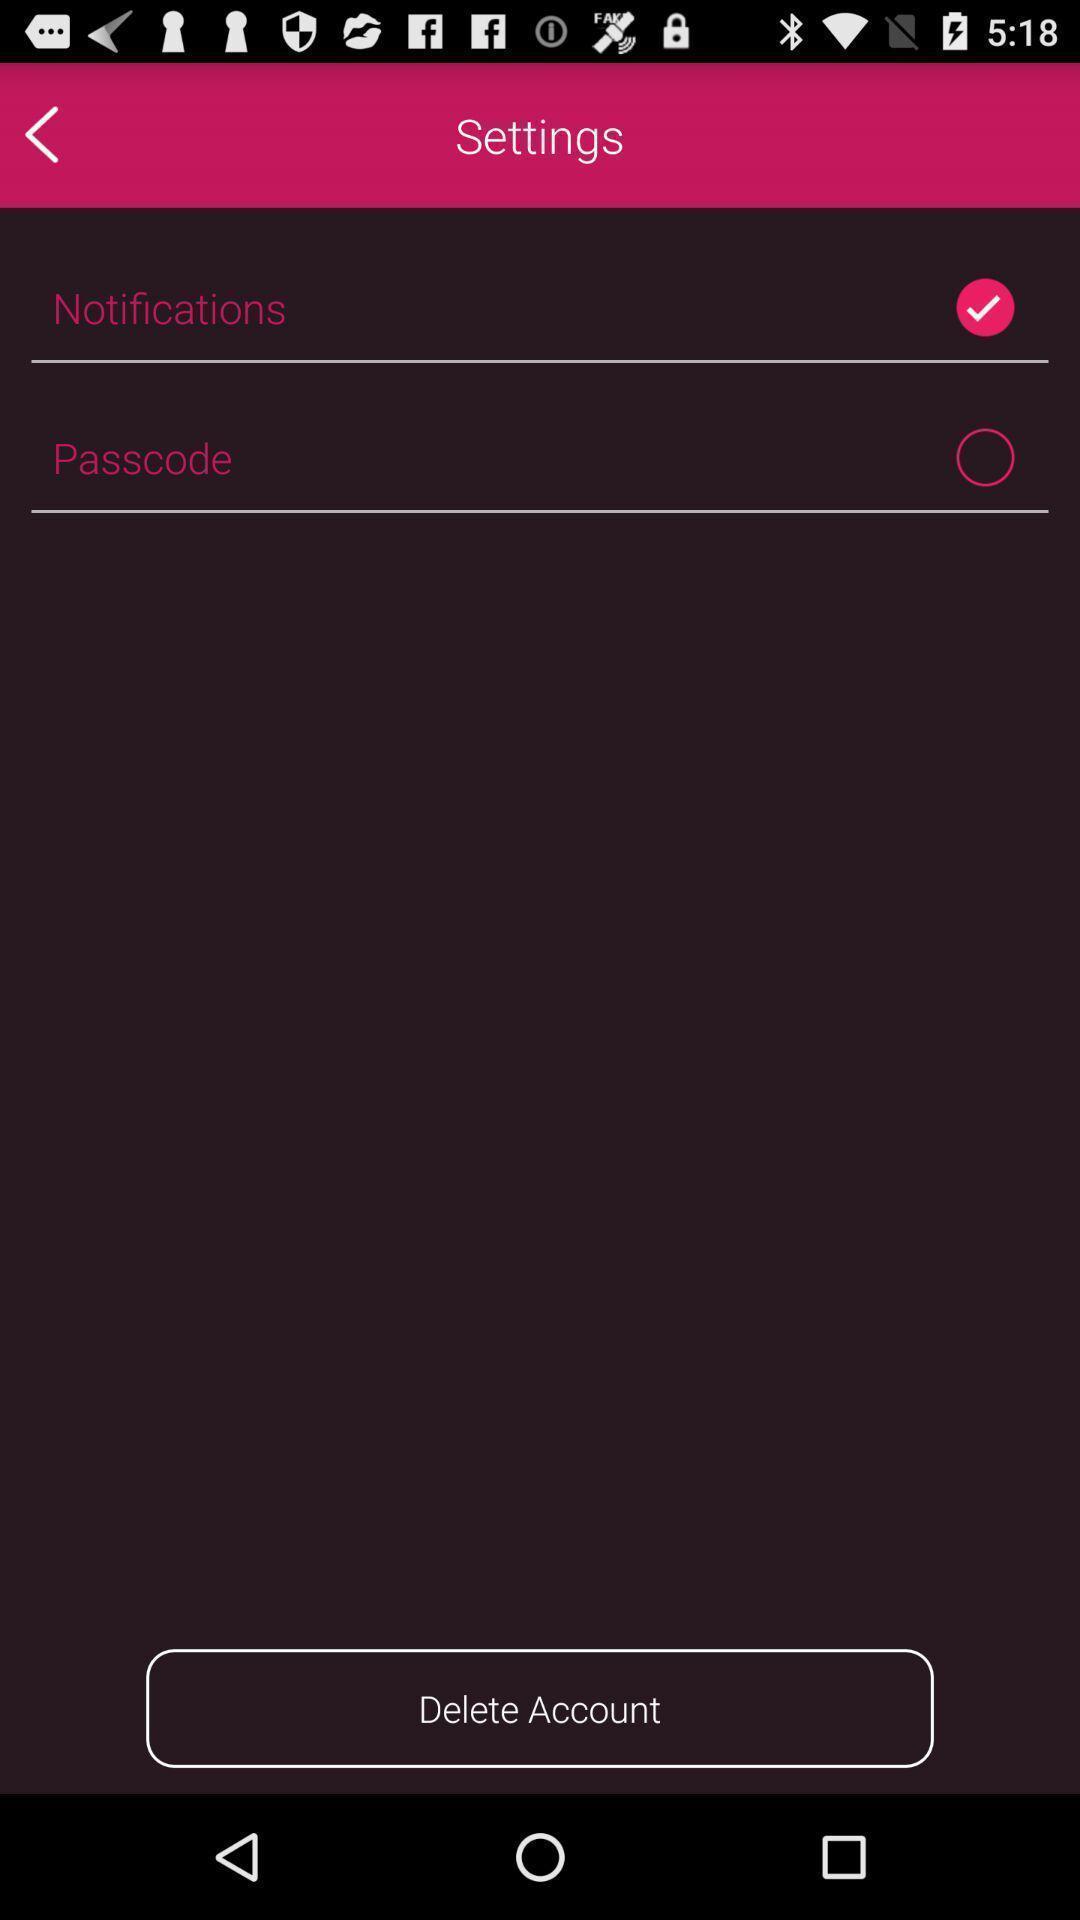Describe the content in this image. Settings tab with two different options in the mobile. 